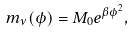Convert formula to latex. <formula><loc_0><loc_0><loc_500><loc_500>m _ { \nu } ( \phi ) = M _ { 0 } e ^ { \beta \phi ^ { 2 } } ,</formula> 